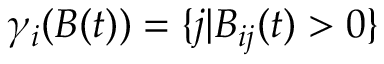Convert formula to latex. <formula><loc_0><loc_0><loc_500><loc_500>\gamma _ { i } ( B ( t ) ) = \{ j | B _ { i j } ( t ) > 0 \}</formula> 